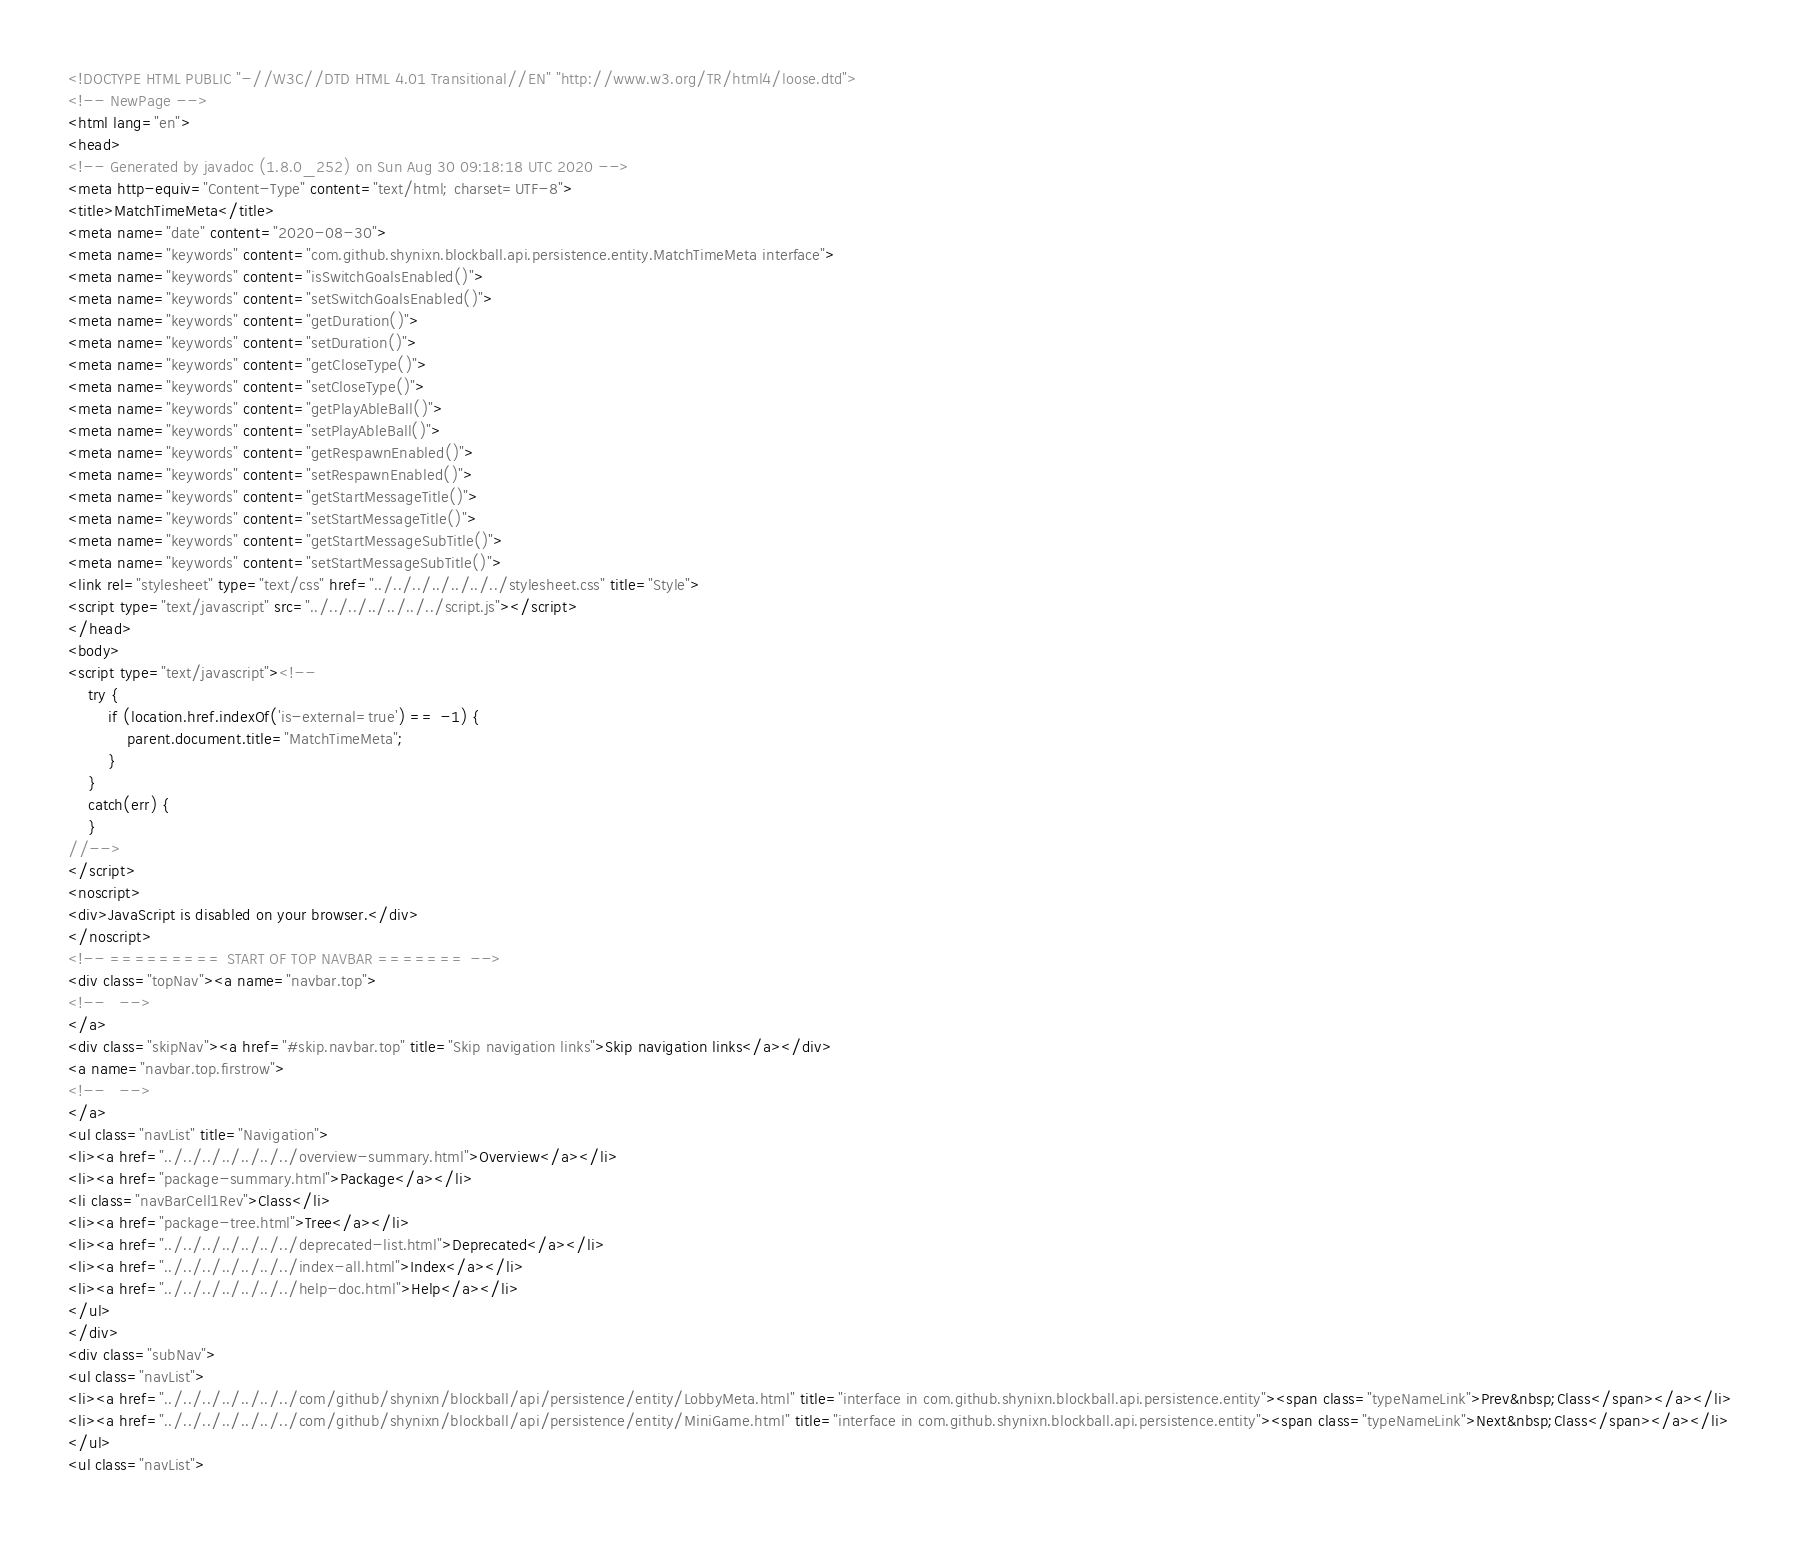<code> <loc_0><loc_0><loc_500><loc_500><_HTML_><!DOCTYPE HTML PUBLIC "-//W3C//DTD HTML 4.01 Transitional//EN" "http://www.w3.org/TR/html4/loose.dtd">
<!-- NewPage -->
<html lang="en">
<head>
<!-- Generated by javadoc (1.8.0_252) on Sun Aug 30 09:18:18 UTC 2020 -->
<meta http-equiv="Content-Type" content="text/html; charset=UTF-8">
<title>MatchTimeMeta</title>
<meta name="date" content="2020-08-30">
<meta name="keywords" content="com.github.shynixn.blockball.api.persistence.entity.MatchTimeMeta interface">
<meta name="keywords" content="isSwitchGoalsEnabled()">
<meta name="keywords" content="setSwitchGoalsEnabled()">
<meta name="keywords" content="getDuration()">
<meta name="keywords" content="setDuration()">
<meta name="keywords" content="getCloseType()">
<meta name="keywords" content="setCloseType()">
<meta name="keywords" content="getPlayAbleBall()">
<meta name="keywords" content="setPlayAbleBall()">
<meta name="keywords" content="getRespawnEnabled()">
<meta name="keywords" content="setRespawnEnabled()">
<meta name="keywords" content="getStartMessageTitle()">
<meta name="keywords" content="setStartMessageTitle()">
<meta name="keywords" content="getStartMessageSubTitle()">
<meta name="keywords" content="setStartMessageSubTitle()">
<link rel="stylesheet" type="text/css" href="../../../../../../../stylesheet.css" title="Style">
<script type="text/javascript" src="../../../../../../../script.js"></script>
</head>
<body>
<script type="text/javascript"><!--
    try {
        if (location.href.indexOf('is-external=true') == -1) {
            parent.document.title="MatchTimeMeta";
        }
    }
    catch(err) {
    }
//-->
</script>
<noscript>
<div>JavaScript is disabled on your browser.</div>
</noscript>
<!-- ========= START OF TOP NAVBAR ======= -->
<div class="topNav"><a name="navbar.top">
<!--   -->
</a>
<div class="skipNav"><a href="#skip.navbar.top" title="Skip navigation links">Skip navigation links</a></div>
<a name="navbar.top.firstrow">
<!--   -->
</a>
<ul class="navList" title="Navigation">
<li><a href="../../../../../../../overview-summary.html">Overview</a></li>
<li><a href="package-summary.html">Package</a></li>
<li class="navBarCell1Rev">Class</li>
<li><a href="package-tree.html">Tree</a></li>
<li><a href="../../../../../../../deprecated-list.html">Deprecated</a></li>
<li><a href="../../../../../../../index-all.html">Index</a></li>
<li><a href="../../../../../../../help-doc.html">Help</a></li>
</ul>
</div>
<div class="subNav">
<ul class="navList">
<li><a href="../../../../../../../com/github/shynixn/blockball/api/persistence/entity/LobbyMeta.html" title="interface in com.github.shynixn.blockball.api.persistence.entity"><span class="typeNameLink">Prev&nbsp;Class</span></a></li>
<li><a href="../../../../../../../com/github/shynixn/blockball/api/persistence/entity/MiniGame.html" title="interface in com.github.shynixn.blockball.api.persistence.entity"><span class="typeNameLink">Next&nbsp;Class</span></a></li>
</ul>
<ul class="navList"></code> 